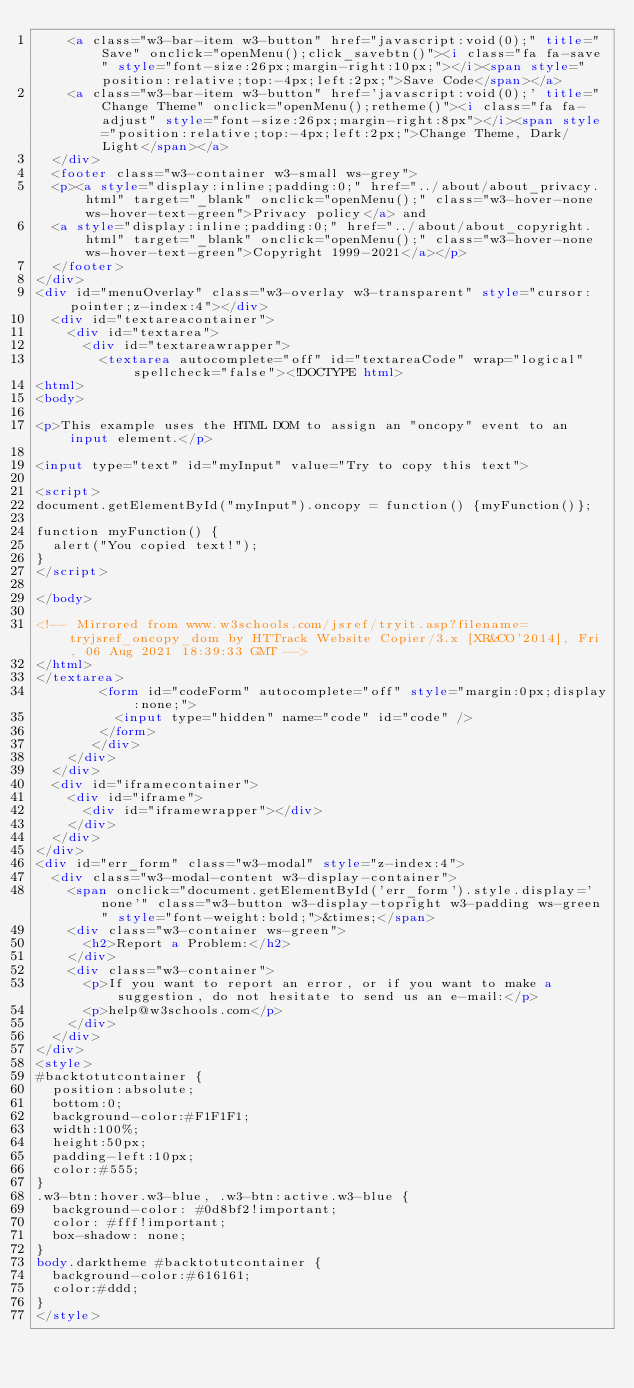<code> <loc_0><loc_0><loc_500><loc_500><_HTML_>    <a class="w3-bar-item w3-button" href="javascript:void(0);" title="Save" onclick="openMenu();click_savebtn()"><i class="fa fa-save" style="font-size:26px;margin-right:10px;"></i><span style="position:relative;top:-4px;left:2px;">Save Code</span></a>
    <a class="w3-bar-item w3-button" href='javascript:void(0);' title="Change Theme" onclick="openMenu();retheme()"><i class="fa fa-adjust" style="font-size:26px;margin-right:8px"></i><span style="position:relative;top:-4px;left:2px;">Change Theme, Dark/Light</span></a>
  </div>
  <footer class="w3-container w3-small ws-grey">
  <p><a style="display:inline;padding:0;" href="../about/about_privacy.html" target="_blank" onclick="openMenu();" class="w3-hover-none ws-hover-text-green">Privacy policy</a> and 
  <a style="display:inline;padding:0;" href="../about/about_copyright.html" target="_blank" onclick="openMenu();" class="w3-hover-none ws-hover-text-green">Copyright 1999-2021</a></p>
  </footer>
</div>
<div id="menuOverlay" class="w3-overlay w3-transparent" style="cursor:pointer;z-index:4"></div>
  <div id="textareacontainer">
    <div id="textarea">
      <div id="textareawrapper">
        <textarea autocomplete="off" id="textareaCode" wrap="logical" spellcheck="false"><!DOCTYPE html>
<html>
<body>

<p>This example uses the HTML DOM to assign an "oncopy" event to an input element.</p>

<input type="text" id="myInput" value="Try to copy this text">

<script>
document.getElementById("myInput").oncopy = function() {myFunction()};

function myFunction() {
  alert("You copied text!");
}
</script>

</body>

<!-- Mirrored from www.w3schools.com/jsref/tryit.asp?filename=tryjsref_oncopy_dom by HTTrack Website Copier/3.x [XR&CO'2014], Fri, 06 Aug 2021 18:39:33 GMT -->
</html>
</textarea>
        <form id="codeForm" autocomplete="off" style="margin:0px;display:none;">
          <input type="hidden" name="code" id="code" />
        </form>
       </div>
    </div>
  </div>
  <div id="iframecontainer">
    <div id="iframe">
      <div id="iframewrapper"></div>
    </div>
  </div>
</div>
<div id="err_form" class="w3-modal" style="z-index:4">
  <div class="w3-modal-content w3-display-container">
    <span onclick="document.getElementById('err_form').style.display='none'" class="w3-button w3-display-topright w3-padding ws-green" style="font-weight:bold;">&times;</span>
    <div class="w3-container ws-green">
      <h2>Report a Problem:</h2>
    </div>
    <div class="w3-container"> 
      <p>If you want to report an error, or if you want to make a suggestion, do not hesitate to send us an e-mail:</p>
      <p>help@w3schools.com</p>
    </div>
  </div>
</div>
<style>
#backtotutcontainer {
  position:absolute;
  bottom:0;
  background-color:#F1F1F1;
  width:100%;
  height:50px;
  padding-left:10px;
  color:#555;
}
.w3-btn:hover.w3-blue, .w3-btn:active.w3-blue {
  background-color: #0d8bf2!important;
  color: #fff!important;
  box-shadow: none;
}
body.darktheme #backtotutcontainer {
  background-color:#616161;
  color:#ddd;
}
</style>
</code> 